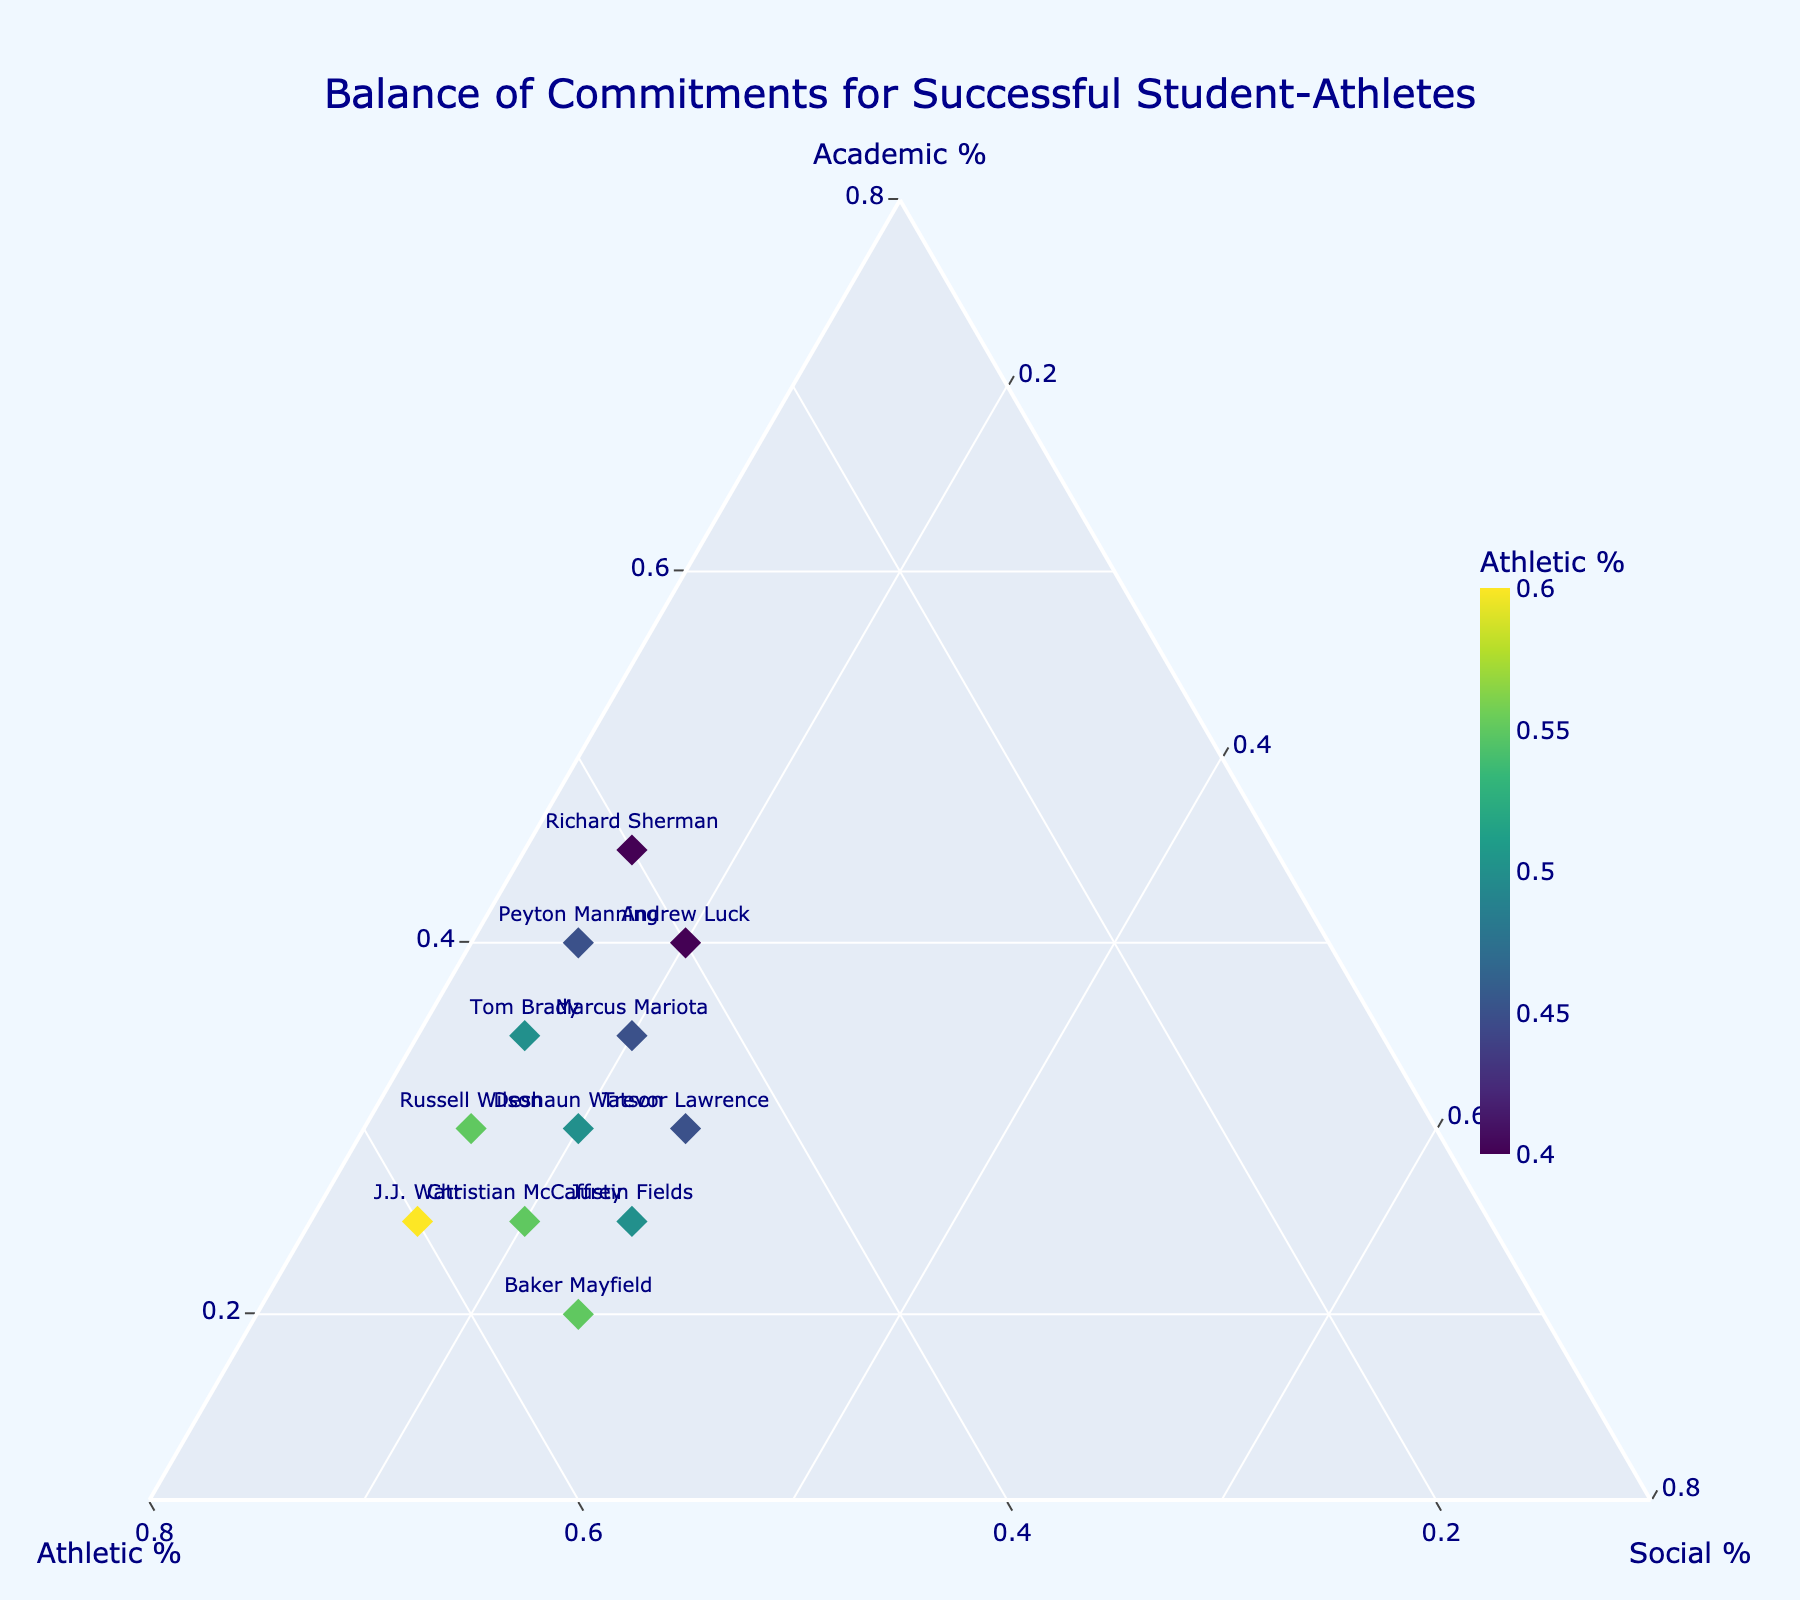what is the title of the figure? The title is displayed at the top of the figure, describing the overall content. It reads "Balance of Commitments for Successful Student-Athletes."
Answer: Balance of Commitments for Successful Student-Athletes How many players allocate 20% of their time to social commitments? By counting the markers labeled with players' names that lie within the 20% social commitment region, we can determine the number of players.
Answer: 4 Which player spends the highest percentage of their time on athletic commitments? By visually inspecting the markers for the highest value along the Athletic % axis, J.J. Watt stands out with 60%.
Answer: J.J. Watt Which player has an equal balance between academic and athletic commitments? By identifying markers for players whose position is equidistant from the Academic and Athletic axes and confirms with their time allocation values, Andrew Luck fits this criteria with 40% each.
Answer: Andrew Luck What is the main color theme of the plot? The overall background and plot colors appear light blue (aliceblue) with dark blue (navy) text and markers colored in a Viridis scale.
Answer: Light blue and dark blue Who spends the least time on academic commitments? By finding the marker with the lowest Academic % value, Baker Mayfield is identified with only 20% academic commitment.
Answer: Baker Mayfield What is the total number of players plotted in the figure? Counting the total markers labeled with each player's name, we ascertain the number of players.
Answer: 12 What is the most common percentage allocated to social commitments among all players? Checking the repeated social commitment values, 15% is the most frequent as it is shared by multiple players.
Answer: 15% Does any player allocate more than 50% of their time to social commitments? By scanning the Social % values for any that exceed 50%, it is clear that none of the players allocate more than 50% to social commitments.
Answer: No 